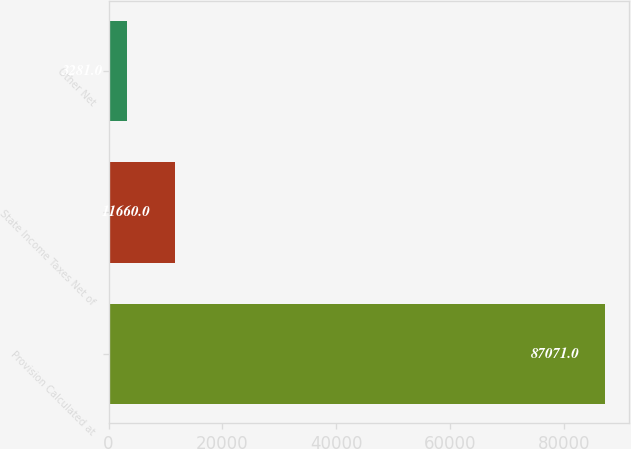Convert chart to OTSL. <chart><loc_0><loc_0><loc_500><loc_500><bar_chart><fcel>Provision Calculated at<fcel>State Income Taxes Net of<fcel>Other Net<nl><fcel>87071<fcel>11660<fcel>3281<nl></chart> 